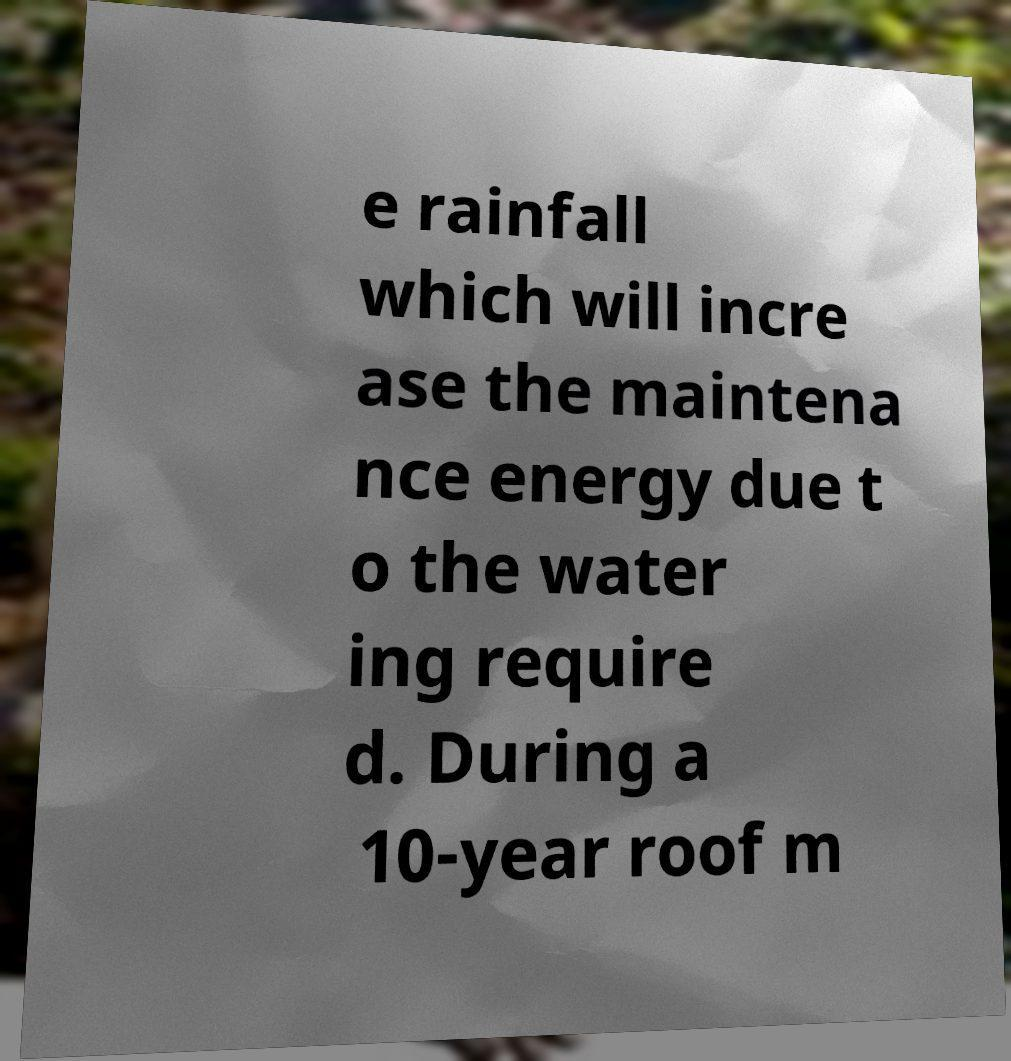Please read and relay the text visible in this image. What does it say? e rainfall which will incre ase the maintena nce energy due t o the water ing require d. During a 10-year roof m 